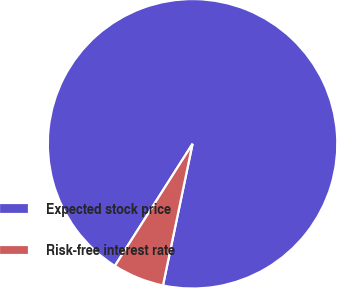Convert chart. <chart><loc_0><loc_0><loc_500><loc_500><pie_chart><fcel>Expected stock price<fcel>Risk-free interest rate<nl><fcel>94.26%<fcel>5.74%<nl></chart> 